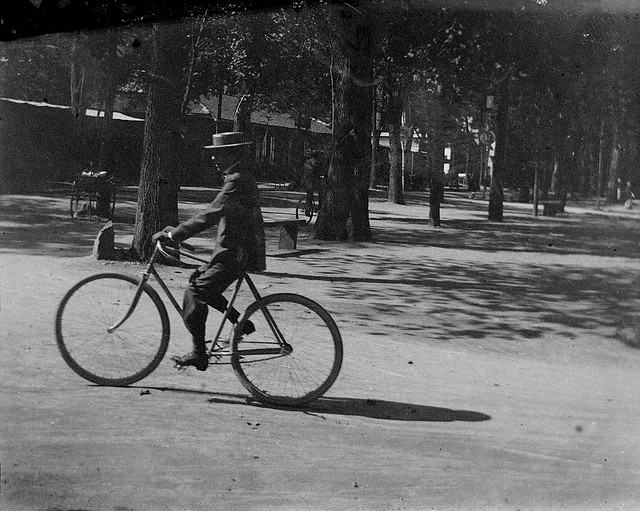<image>How fast is the bike moving? It is unknown how fast the bike is moving. It could be moving slowly or fast. How fast is the bike moving? I don't know how fast the bike is moving. It can be moving slowly or not fast. 